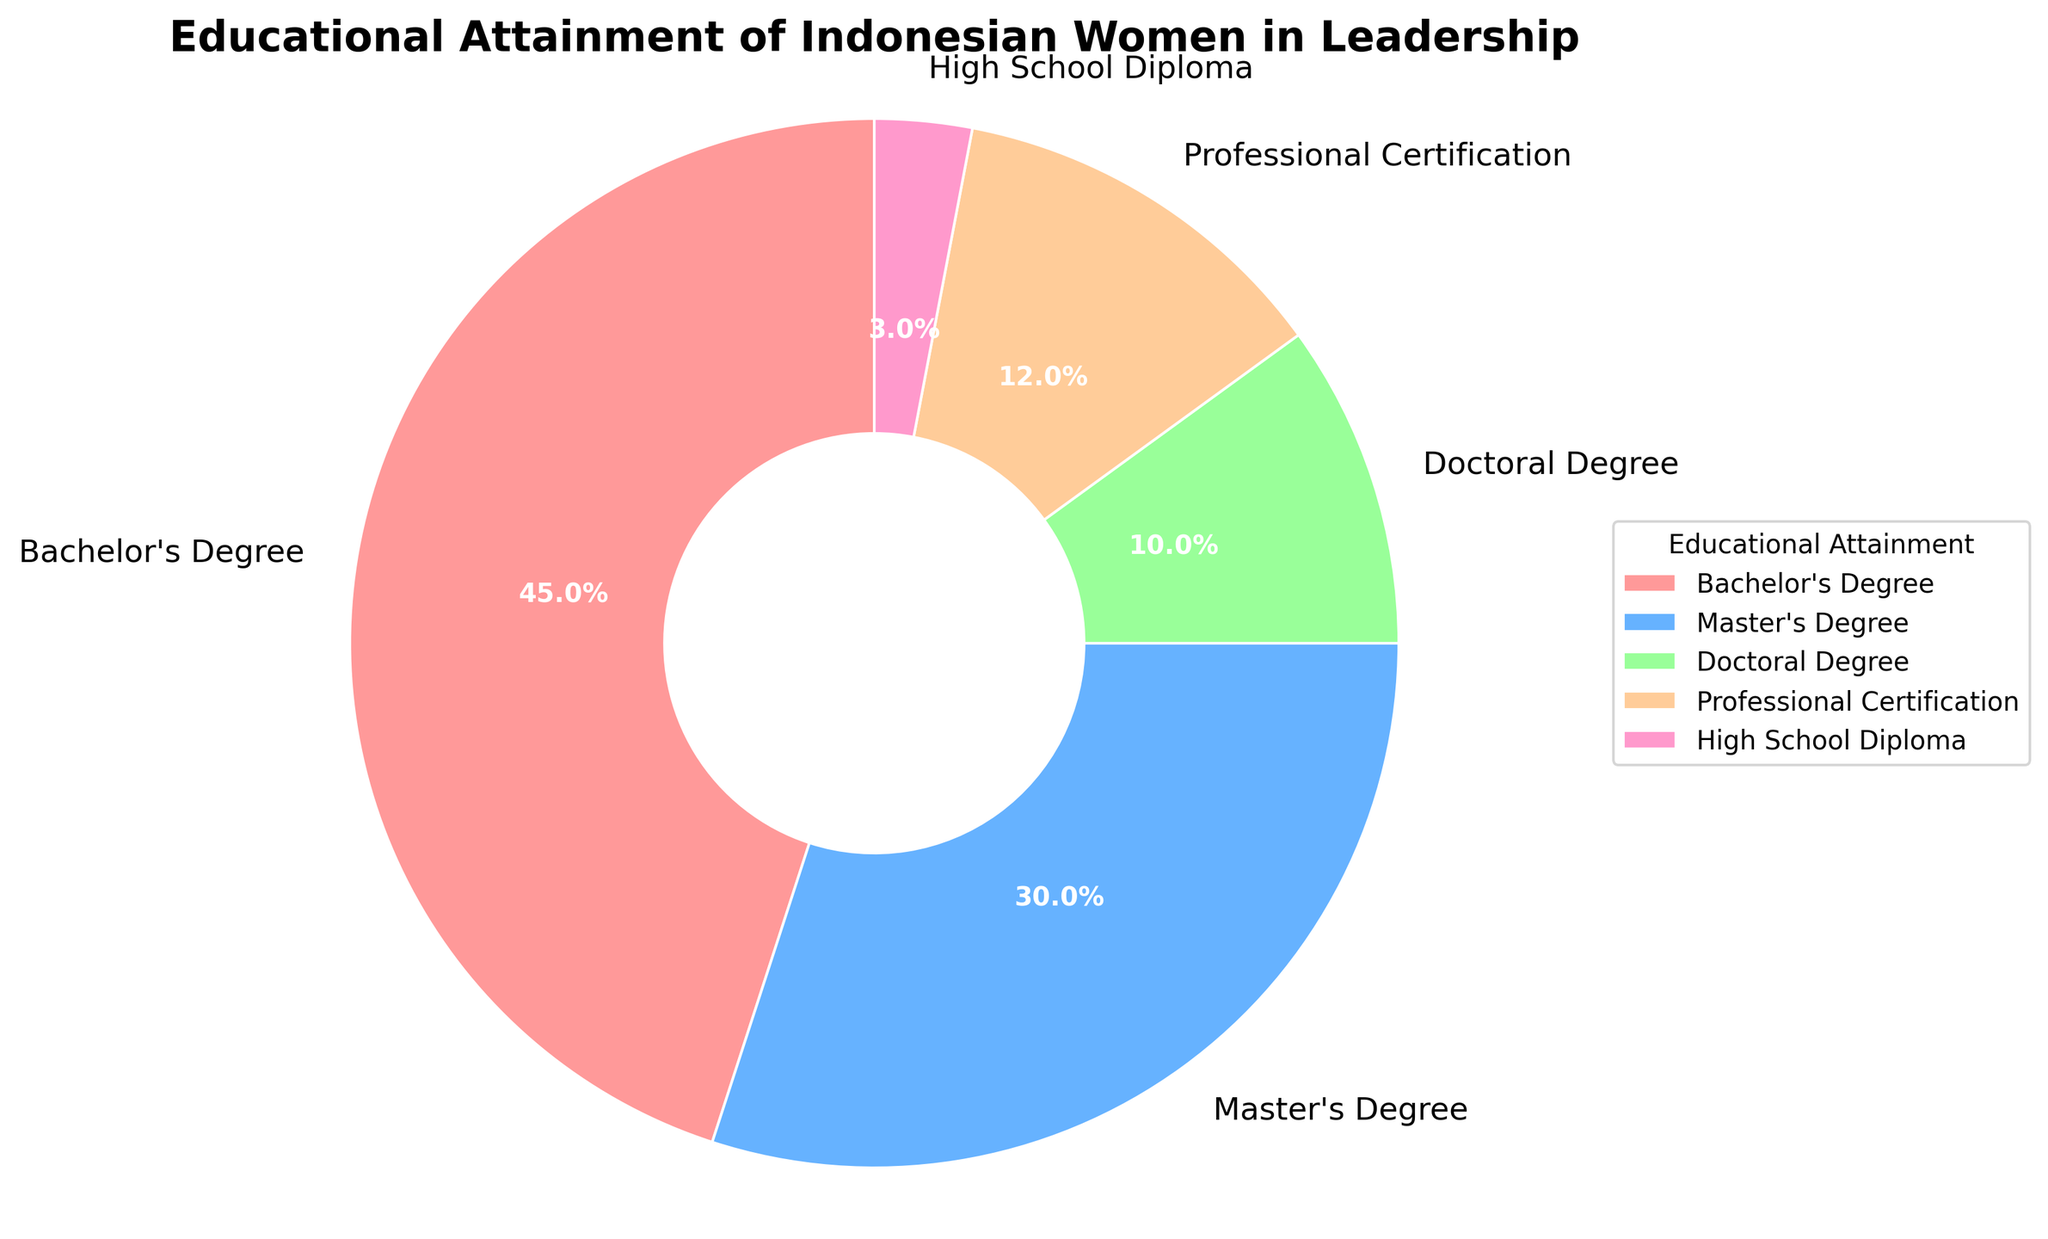What is the most common educational attainment among Indonesian women in leadership? By looking at the largest section of the pie chart, which represents the highest percentage, we can identify the most common educational attainment. The largest section corresponds to Bachelor's Degree, which has a 45% share.
Answer: Bachelor's Degree What is the combined percentage of Indonesian women in leadership who hold at least a Master's Degree? To find the combined percentage of Master's Degree and Doctoral Degree holders, we add the two percentages together. The Master's Degree has 30%, and the Doctoral Degree has 10%. So, 30% + 10% = 40%.
Answer: 40% Which educational attainment has the smallest representation among Indonesian women in leadership, and what is its percentage? By identifying the smallest section of the pie chart, we can determine this. The smallest slice corresponds to a High School Diploma with a 3% share.
Answer: High School Diploma, 3% How much more prevalent is a Bachelor's Degree compared to a Professional Certification among Indonesian women in leadership? To find the difference between the percentages of women holding a Bachelor's Degree and those with Professional Certification, we subtract the smaller percentage from the larger one. That is, 45% - 12% = 33%.
Answer: 33% What proportion of Indonesian women in leadership have attained education higher than a Bachelor's Degree (include master's, doctoral, and professional certifications)? Adding the percentages for Master's Degree, Doctoral Degree, and Professional Certifications together gives us 30% (Master's) + 10% (Doctoral) + 12% (Professional Certification) = 52%.
Answer: 52% Are there more Indonesian women in leadership with a Doctoral Degree or a Professional Certification? By comparing the percentages on the pie chart, we can see that Professional Certification (12%) is more common than Doctoral Degree (10%).
Answer: Professional Certification What is the percentage difference between those with a High School Diploma and those with any form of tertiary education (Bachelor's, Master's, Doctoral, Professional Certification)? First, calculate the total percentage of those with tertiary education: 45% (Bachelor's) + 30% (Master's) + 10% (Doctoral) + 12% (Professional Certification) = 97%. Then subtract the percentage of High School Diploma holders: 97% - 3% = 94%.
Answer: 94% How does the percentage of Indonesian women in leadership with Master's Degrees compare to those with Bachelor's Degrees? Compare the percentages directly. Since Master's Degree holders account for 30% and Bachelor's Degree holders account for 45%, Bachelor's Degrees are more common.
Answer: Bachelor's Degree holders are more common What are the textual and color indicators of the smallest educational segment? Visually inspecting the pie chart, the section with the smallest slice has the label 'High School Diploma' and the color pink.
Answer: High School Diploma, pink What is the average percentage for each educational category among Indonesian women in leadership? To find the average, sum all the percentages and divide by the number of categories. Sum: 45% (Bachelor's) + 30% (Master's) + 10% (Doctoral) + 12% (Professional Certification) + 3% (High School) = 100%. The number of categories is 5. Average = 100% / 5 = 20%.
Answer: 20% 